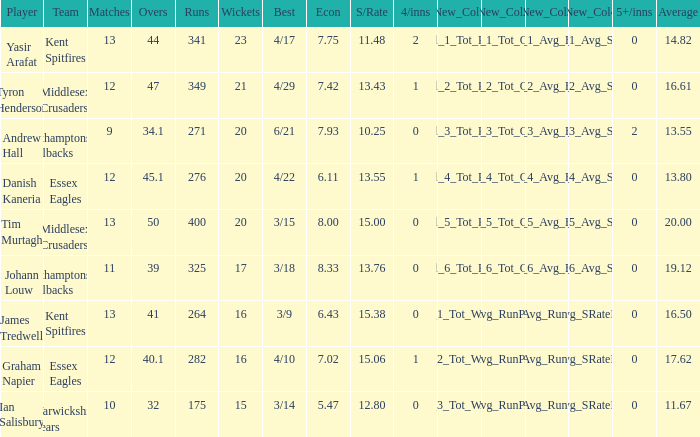Name the matches for wickets 17 11.0. 